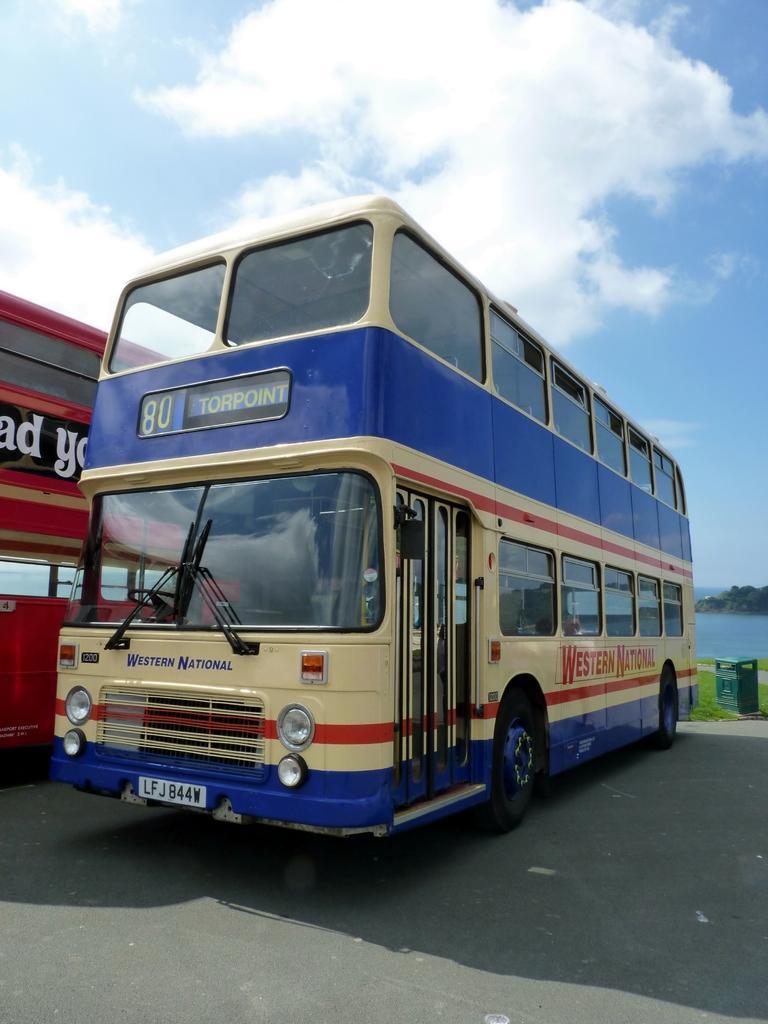How would you summarize this image in a sentence or two? In this image we can see buses on the road, in the background there is a trash bin on the ground and there are mountains, water and the sky with clouds. 